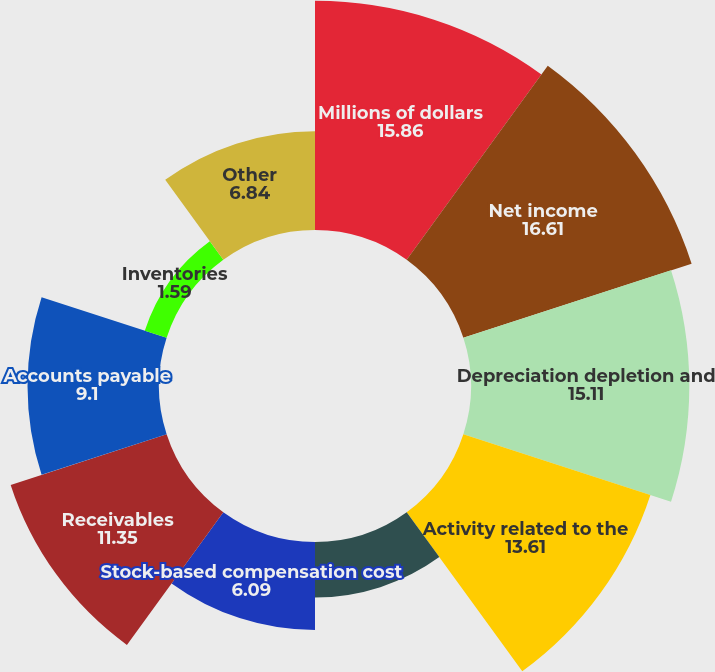<chart> <loc_0><loc_0><loc_500><loc_500><pie_chart><fcel>Millions of dollars<fcel>Net income<fcel>Depreciation depletion and<fcel>Activity related to the<fcel>Deferred income tax (benefit)<fcel>Stock-based compensation cost<fcel>Receivables<fcel>Accounts payable<fcel>Inventories<fcel>Other<nl><fcel>15.86%<fcel>16.61%<fcel>15.11%<fcel>13.61%<fcel>3.84%<fcel>6.09%<fcel>11.35%<fcel>9.1%<fcel>1.59%<fcel>6.84%<nl></chart> 